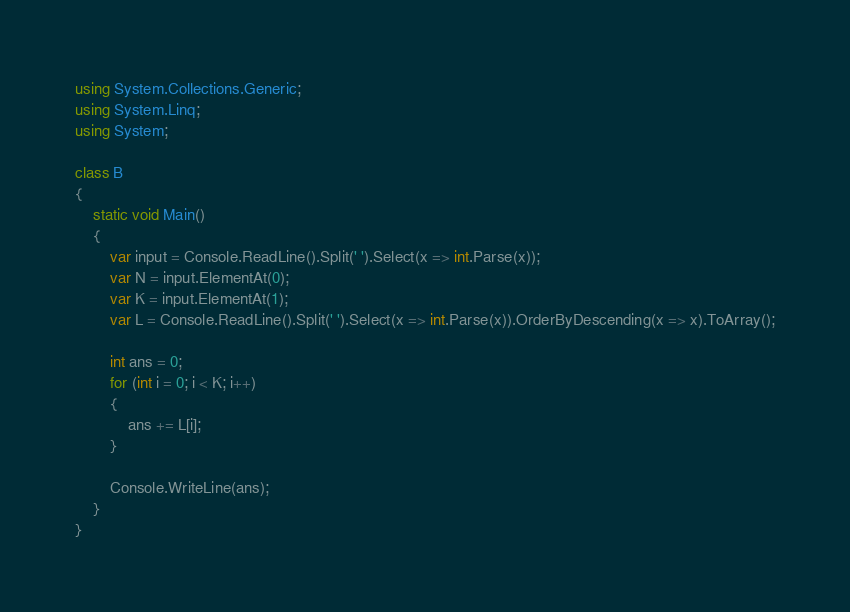<code> <loc_0><loc_0><loc_500><loc_500><_C#_>using System.Collections.Generic;
using System.Linq;
using System;

class B
{
    static void Main()
    {
        var input = Console.ReadLine().Split(' ').Select(x => int.Parse(x));
        var N = input.ElementAt(0);
        var K = input.ElementAt(1);
        var L = Console.ReadLine().Split(' ').Select(x => int.Parse(x)).OrderByDescending(x => x).ToArray();

        int ans = 0;
        for (int i = 0; i < K; i++)
        {
            ans += L[i];
        }

        Console.WriteLine(ans);
    }
}</code> 